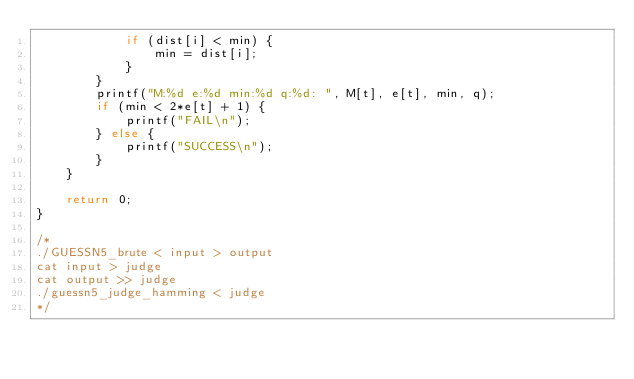Convert code to text. <code><loc_0><loc_0><loc_500><loc_500><_C++_>            if (dist[i] < min) {
                min = dist[i];
            }
        }
        printf("M:%d e:%d min:%d q:%d: ", M[t], e[t], min, q);
        if (min < 2*e[t] + 1) {
            printf("FAIL\n");
        } else {
            printf("SUCCESS\n");
        }
    }

    return 0;
}

/*
./GUESSN5_brute < input > output
cat input > judge
cat output >> judge
./guessn5_judge_hamming < judge
*/</code> 